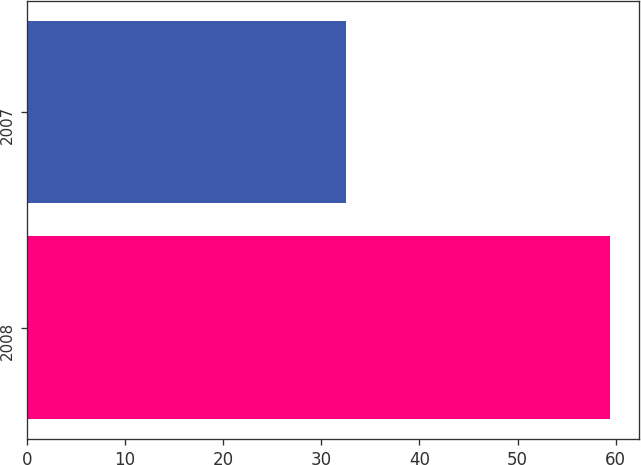<chart> <loc_0><loc_0><loc_500><loc_500><bar_chart><fcel>2008<fcel>2007<nl><fcel>59.4<fcel>32.5<nl></chart> 